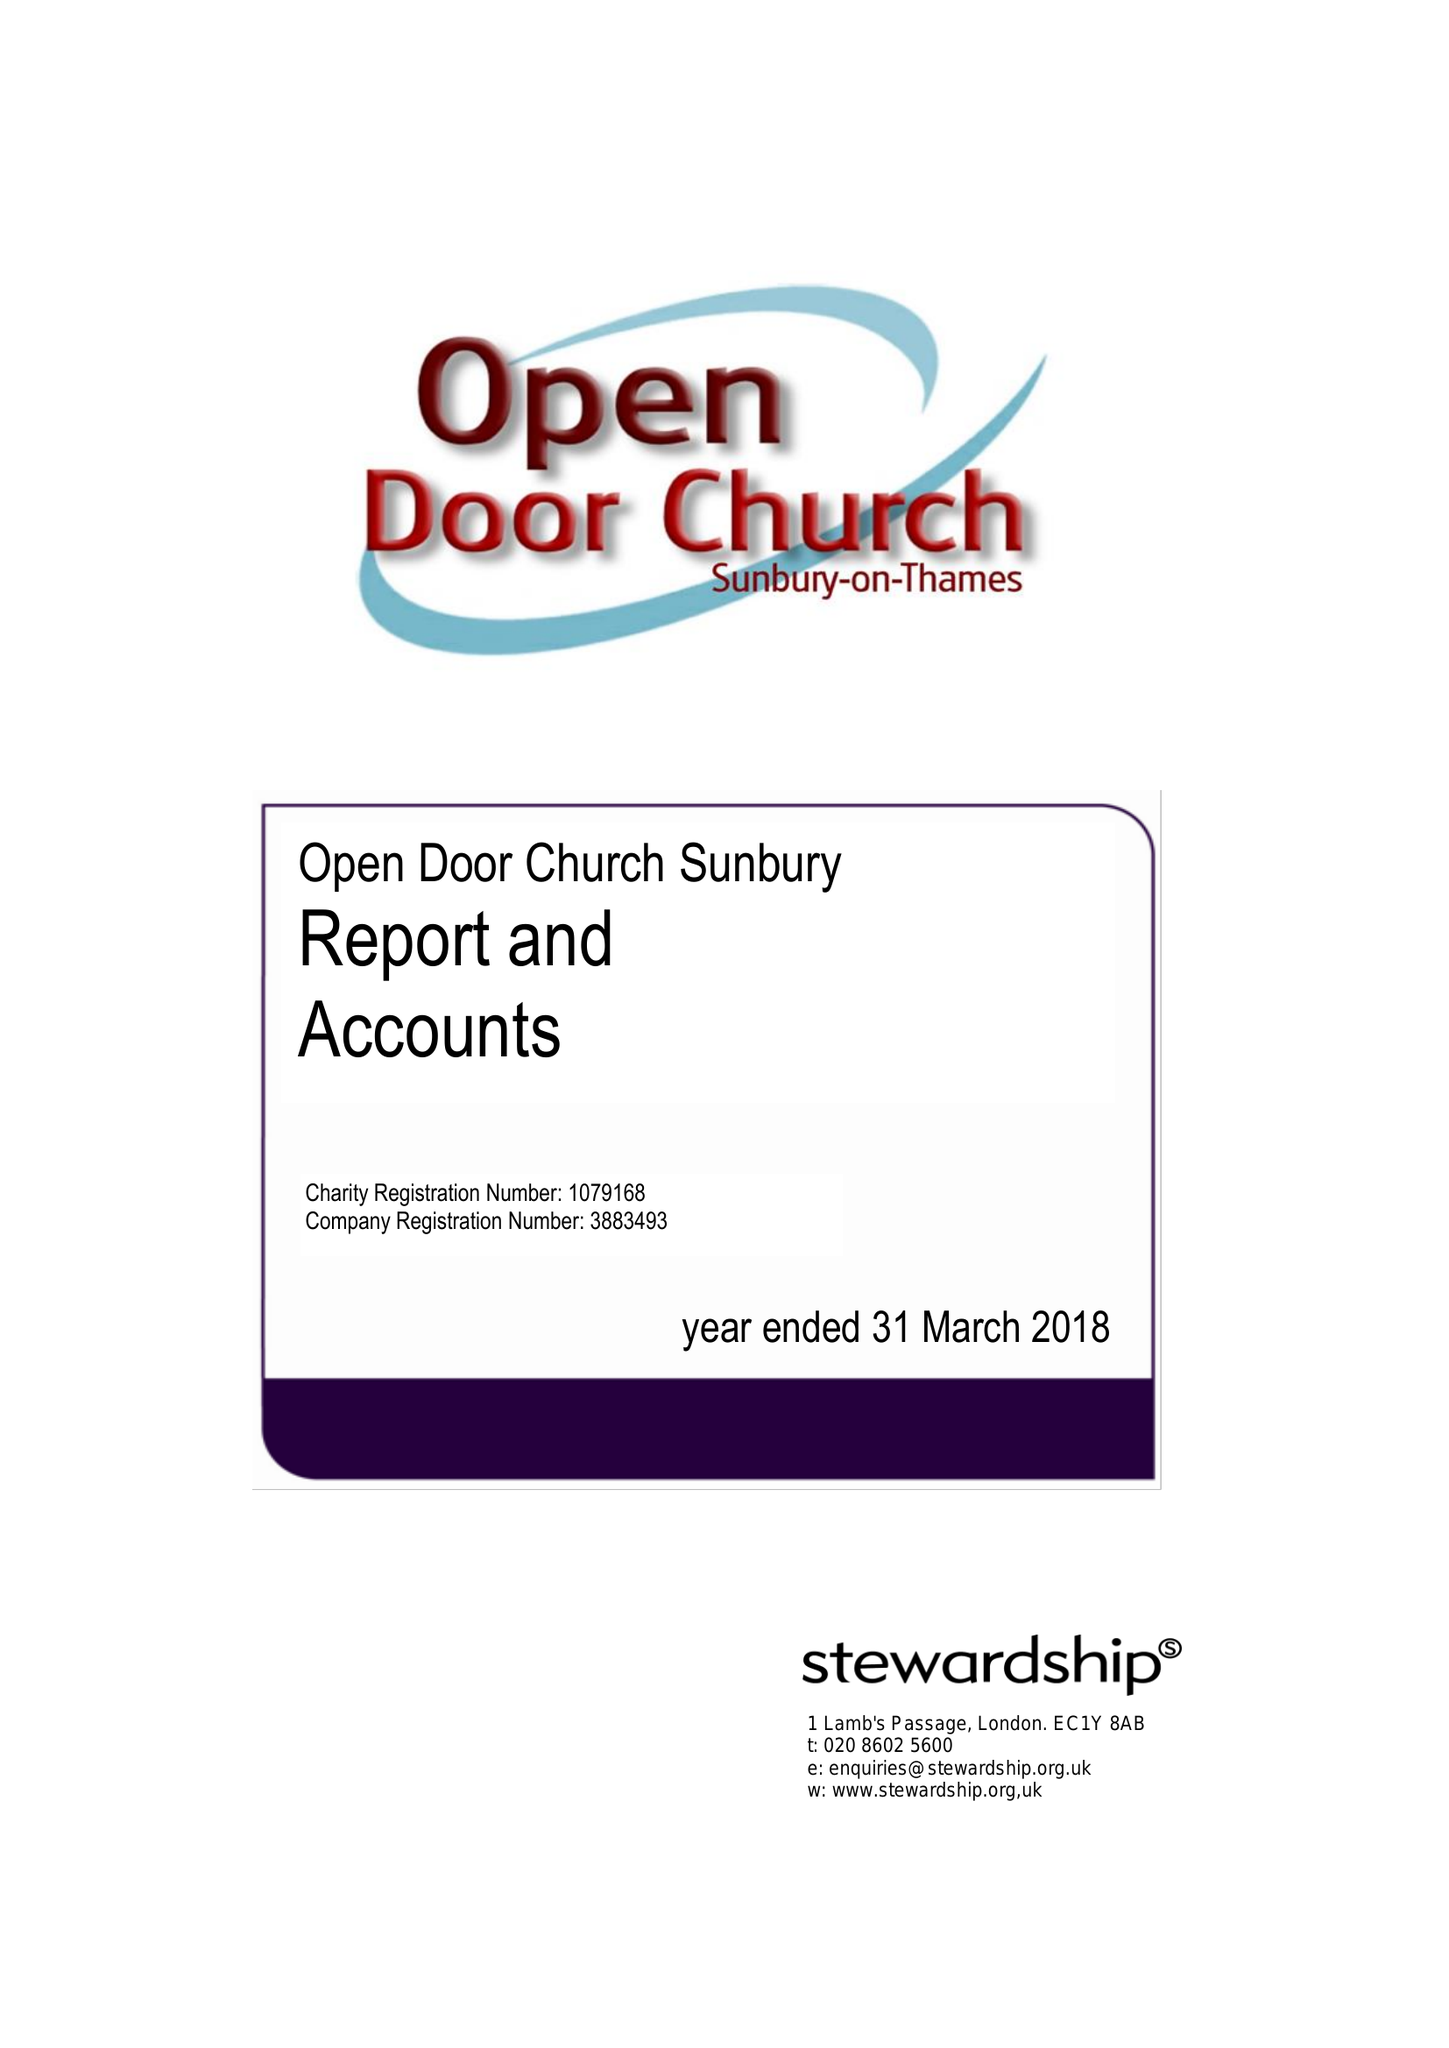What is the value for the charity_name?
Answer the question using a single word or phrase. Open Door Church Sunbury 